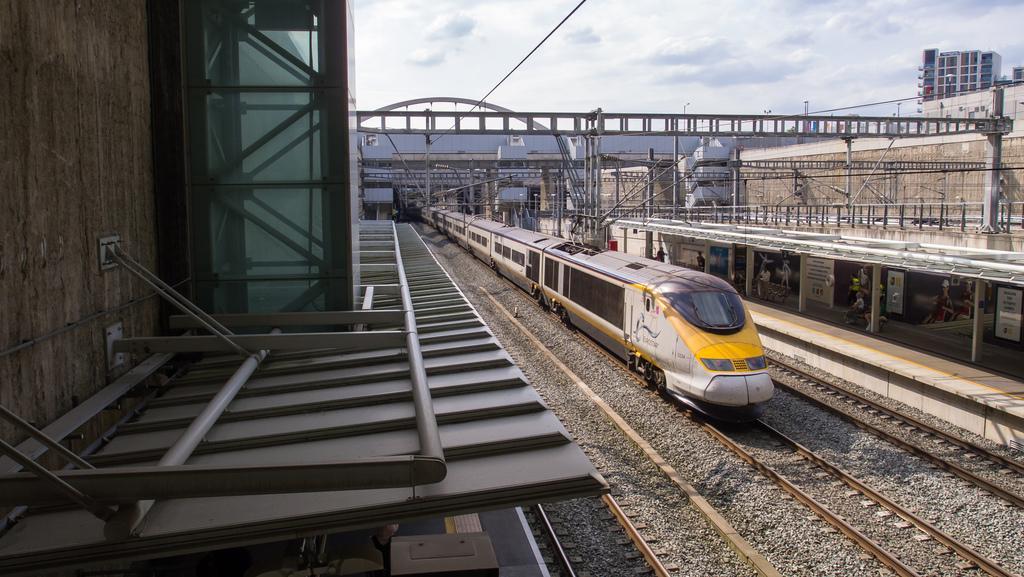Could you give a brief overview of what you see in this image? In this image we can see railway tracks. On that there is a train. Also there are arches, rods, railings and pillars. On the right side there is a wall with stands. In the background there is sky with clouds. Also there is a building. 